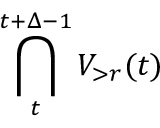Convert formula to latex. <formula><loc_0><loc_0><loc_500><loc_500>\bigcap _ { t } ^ { t + \Delta - 1 } { V } _ { > r } ( t )</formula> 